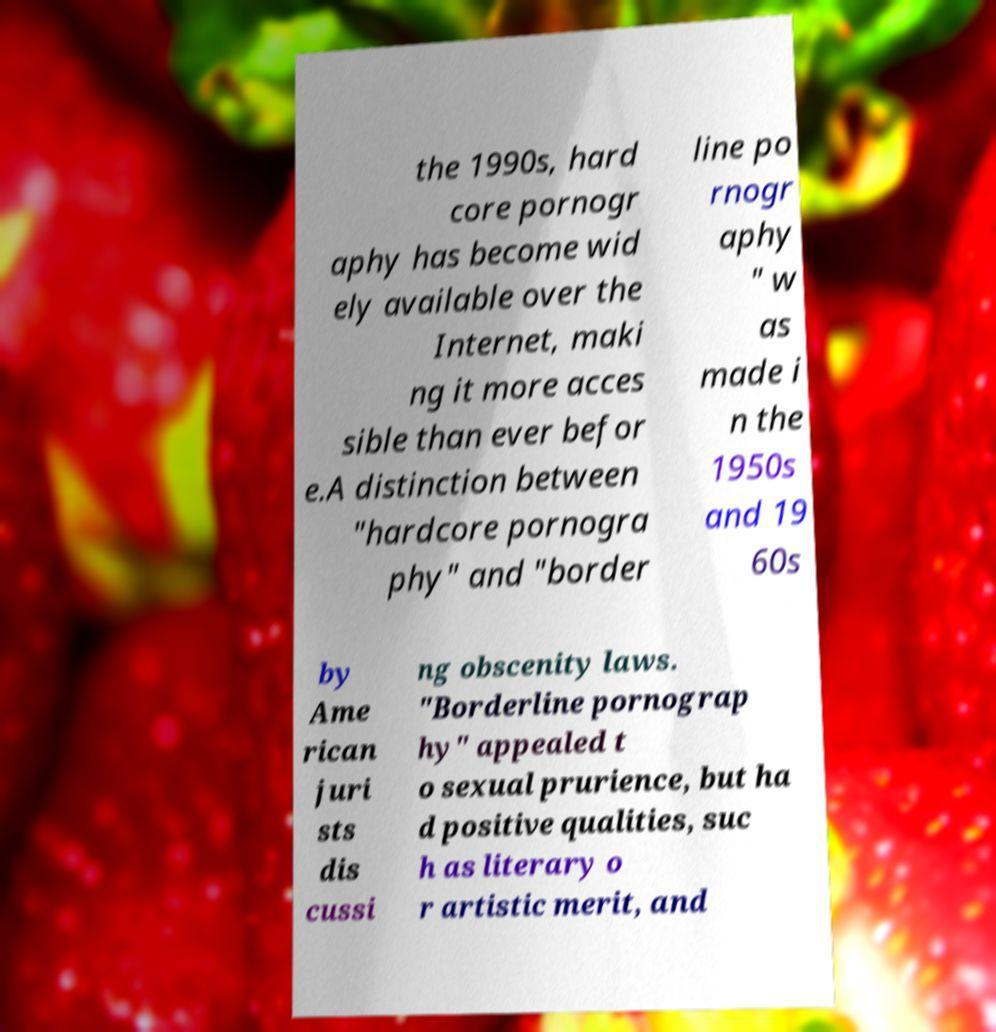Could you extract and type out the text from this image? the 1990s, hard core pornogr aphy has become wid ely available over the Internet, maki ng it more acces sible than ever befor e.A distinction between "hardcore pornogra phy" and "border line po rnogr aphy " w as made i n the 1950s and 19 60s by Ame rican juri sts dis cussi ng obscenity laws. "Borderline pornograp hy" appealed t o sexual prurience, but ha d positive qualities, suc h as literary o r artistic merit, and 